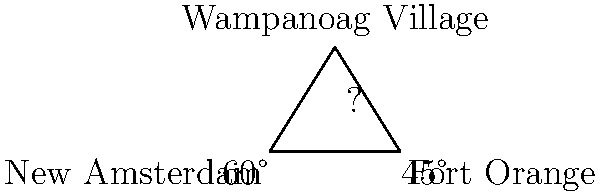Two early Dutch colonial settlements, New Amsterdam and Fort Orange, are separated by a distance of 150 miles. A Wampanoag village is located at an unknown distance from both settlements. From New Amsterdam, the angle between Fort Orange and the Wampanoag village is 60°. From Fort Orange, the angle between New Amsterdam and the Wampanoag village is 45°. Using trigonometric ratios, determine the distance between New Amsterdam and the Wampanoag village. Let's approach this step-by-step:

1) Let's denote:
   - New Amsterdam as point A
   - Fort Orange as point B
   - Wampanoag village as point C

2) We know:
   - AB = 150 miles
   - Angle BAC = 60°
   - Angle ABC = 45°

3) In triangle ABC, we can find the third angle:
   Angle ACB = 180° - 60° - 45° = 75°

4) We can use the sine law:
   $$\frac{a}{\sin A} = \frac{b}{\sin B} = \frac{c}{\sin C}$$

   Where a, b, c are the sides opposite to angles A, B, C respectively.

5) We want to find AC. Let's use:
   $$\frac{AC}{\sin 45°} = \frac{150}{\sin 75°}$$

6) Rearranging:
   $$AC = \frac{150 \sin 45°}{\sin 75°}$$

7) Now, let's calculate:
   $$AC = \frac{150 \cdot \frac{\sqrt{2}}{2}}{\frac{\sqrt{6}+\sqrt{2}}{4}}$$

8) Simplifying:
   $$AC = \frac{150 \sqrt{2} \cdot 4}{2(\sqrt{6}+\sqrt{2})} = \frac{300\sqrt{2}}{\sqrt{6}+\sqrt{2}} \approx 130.9$$

Therefore, the distance between New Amsterdam and the Wampanoag village is approximately 130.9 miles.
Answer: 130.9 miles 